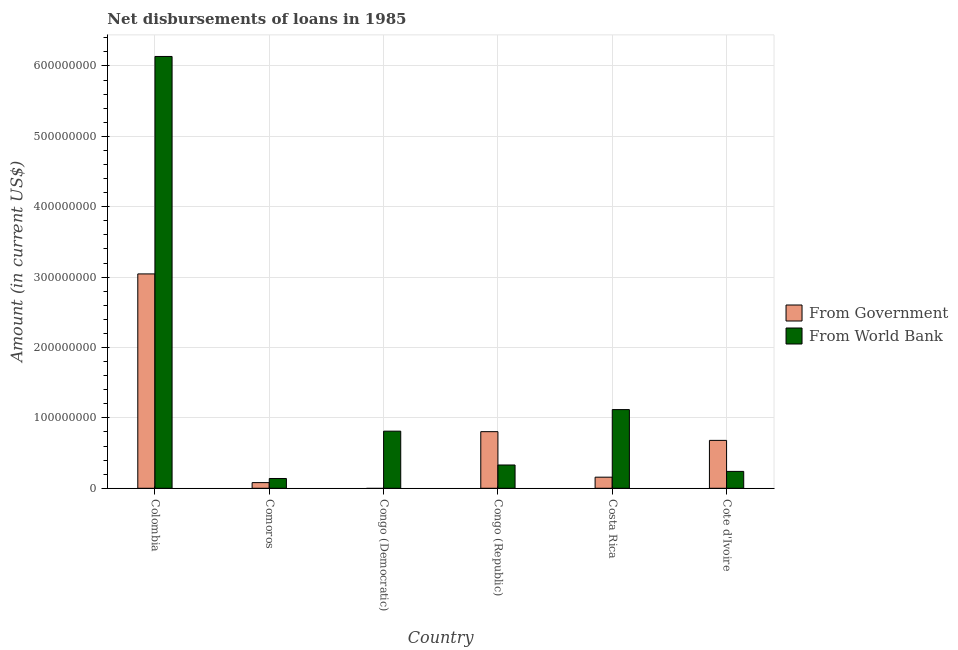How many different coloured bars are there?
Offer a very short reply. 2. How many bars are there on the 5th tick from the left?
Your answer should be compact. 2. What is the label of the 1st group of bars from the left?
Keep it short and to the point. Colombia. In how many cases, is the number of bars for a given country not equal to the number of legend labels?
Ensure brevity in your answer.  1. What is the net disbursements of loan from government in Congo (Democratic)?
Offer a very short reply. 0. Across all countries, what is the maximum net disbursements of loan from world bank?
Your response must be concise. 6.13e+08. Across all countries, what is the minimum net disbursements of loan from government?
Your answer should be very brief. 0. In which country was the net disbursements of loan from world bank maximum?
Offer a terse response. Colombia. What is the total net disbursements of loan from world bank in the graph?
Keep it short and to the point. 8.77e+08. What is the difference between the net disbursements of loan from world bank in Colombia and that in Congo (Republic)?
Ensure brevity in your answer.  5.80e+08. What is the difference between the net disbursements of loan from world bank in Congo (Democratic) and the net disbursements of loan from government in Colombia?
Keep it short and to the point. -2.23e+08. What is the average net disbursements of loan from government per country?
Provide a succinct answer. 7.95e+07. What is the difference between the net disbursements of loan from government and net disbursements of loan from world bank in Comoros?
Keep it short and to the point. -5.86e+06. In how many countries, is the net disbursements of loan from world bank greater than 340000000 US$?
Give a very brief answer. 1. What is the ratio of the net disbursements of loan from world bank in Congo (Republic) to that in Costa Rica?
Ensure brevity in your answer.  0.3. Is the difference between the net disbursements of loan from world bank in Colombia and Congo (Republic) greater than the difference between the net disbursements of loan from government in Colombia and Congo (Republic)?
Ensure brevity in your answer.  Yes. What is the difference between the highest and the second highest net disbursements of loan from government?
Provide a succinct answer. 2.24e+08. What is the difference between the highest and the lowest net disbursements of loan from government?
Your answer should be compact. 3.05e+08. In how many countries, is the net disbursements of loan from government greater than the average net disbursements of loan from government taken over all countries?
Keep it short and to the point. 2. Are all the bars in the graph horizontal?
Provide a succinct answer. No. Does the graph contain grids?
Your answer should be compact. Yes. Where does the legend appear in the graph?
Your answer should be very brief. Center right. How many legend labels are there?
Give a very brief answer. 2. How are the legend labels stacked?
Ensure brevity in your answer.  Vertical. What is the title of the graph?
Ensure brevity in your answer.  Net disbursements of loans in 1985. What is the label or title of the X-axis?
Make the answer very short. Country. What is the label or title of the Y-axis?
Ensure brevity in your answer.  Amount (in current US$). What is the Amount (in current US$) in From Government in Colombia?
Keep it short and to the point. 3.05e+08. What is the Amount (in current US$) in From World Bank in Colombia?
Keep it short and to the point. 6.13e+08. What is the Amount (in current US$) of From Government in Comoros?
Give a very brief answer. 8.06e+06. What is the Amount (in current US$) of From World Bank in Comoros?
Offer a very short reply. 1.39e+07. What is the Amount (in current US$) of From Government in Congo (Democratic)?
Provide a short and direct response. 0. What is the Amount (in current US$) in From World Bank in Congo (Democratic)?
Your answer should be very brief. 8.11e+07. What is the Amount (in current US$) in From Government in Congo (Republic)?
Ensure brevity in your answer.  8.04e+07. What is the Amount (in current US$) in From World Bank in Congo (Republic)?
Make the answer very short. 3.31e+07. What is the Amount (in current US$) in From Government in Costa Rica?
Make the answer very short. 1.58e+07. What is the Amount (in current US$) of From World Bank in Costa Rica?
Offer a very short reply. 1.12e+08. What is the Amount (in current US$) of From Government in Cote d'Ivoire?
Give a very brief answer. 6.80e+07. What is the Amount (in current US$) in From World Bank in Cote d'Ivoire?
Provide a short and direct response. 2.40e+07. Across all countries, what is the maximum Amount (in current US$) in From Government?
Your answer should be very brief. 3.05e+08. Across all countries, what is the maximum Amount (in current US$) in From World Bank?
Offer a terse response. 6.13e+08. Across all countries, what is the minimum Amount (in current US$) of From World Bank?
Provide a short and direct response. 1.39e+07. What is the total Amount (in current US$) of From Government in the graph?
Keep it short and to the point. 4.77e+08. What is the total Amount (in current US$) in From World Bank in the graph?
Your answer should be compact. 8.77e+08. What is the difference between the Amount (in current US$) in From Government in Colombia and that in Comoros?
Keep it short and to the point. 2.96e+08. What is the difference between the Amount (in current US$) of From World Bank in Colombia and that in Comoros?
Make the answer very short. 6.00e+08. What is the difference between the Amount (in current US$) of From World Bank in Colombia and that in Congo (Democratic)?
Provide a succinct answer. 5.32e+08. What is the difference between the Amount (in current US$) of From Government in Colombia and that in Congo (Republic)?
Provide a short and direct response. 2.24e+08. What is the difference between the Amount (in current US$) of From World Bank in Colombia and that in Congo (Republic)?
Ensure brevity in your answer.  5.80e+08. What is the difference between the Amount (in current US$) in From Government in Colombia and that in Costa Rica?
Ensure brevity in your answer.  2.89e+08. What is the difference between the Amount (in current US$) in From World Bank in Colombia and that in Costa Rica?
Provide a short and direct response. 5.02e+08. What is the difference between the Amount (in current US$) of From Government in Colombia and that in Cote d'Ivoire?
Your answer should be very brief. 2.36e+08. What is the difference between the Amount (in current US$) of From World Bank in Colombia and that in Cote d'Ivoire?
Your response must be concise. 5.89e+08. What is the difference between the Amount (in current US$) of From World Bank in Comoros and that in Congo (Democratic)?
Provide a short and direct response. -6.72e+07. What is the difference between the Amount (in current US$) in From Government in Comoros and that in Congo (Republic)?
Provide a succinct answer. -7.24e+07. What is the difference between the Amount (in current US$) of From World Bank in Comoros and that in Congo (Republic)?
Offer a terse response. -1.92e+07. What is the difference between the Amount (in current US$) of From Government in Comoros and that in Costa Rica?
Your answer should be compact. -7.72e+06. What is the difference between the Amount (in current US$) in From World Bank in Comoros and that in Costa Rica?
Provide a short and direct response. -9.79e+07. What is the difference between the Amount (in current US$) in From Government in Comoros and that in Cote d'Ivoire?
Your answer should be very brief. -6.00e+07. What is the difference between the Amount (in current US$) in From World Bank in Comoros and that in Cote d'Ivoire?
Your answer should be compact. -1.01e+07. What is the difference between the Amount (in current US$) of From World Bank in Congo (Democratic) and that in Congo (Republic)?
Offer a very short reply. 4.81e+07. What is the difference between the Amount (in current US$) of From World Bank in Congo (Democratic) and that in Costa Rica?
Keep it short and to the point. -3.06e+07. What is the difference between the Amount (in current US$) in From World Bank in Congo (Democratic) and that in Cote d'Ivoire?
Provide a succinct answer. 5.72e+07. What is the difference between the Amount (in current US$) of From Government in Congo (Republic) and that in Costa Rica?
Ensure brevity in your answer.  6.47e+07. What is the difference between the Amount (in current US$) in From World Bank in Congo (Republic) and that in Costa Rica?
Give a very brief answer. -7.87e+07. What is the difference between the Amount (in current US$) of From Government in Congo (Republic) and that in Cote d'Ivoire?
Provide a succinct answer. 1.24e+07. What is the difference between the Amount (in current US$) of From World Bank in Congo (Republic) and that in Cote d'Ivoire?
Offer a terse response. 9.10e+06. What is the difference between the Amount (in current US$) in From Government in Costa Rica and that in Cote d'Ivoire?
Ensure brevity in your answer.  -5.23e+07. What is the difference between the Amount (in current US$) in From World Bank in Costa Rica and that in Cote d'Ivoire?
Make the answer very short. 8.78e+07. What is the difference between the Amount (in current US$) of From Government in Colombia and the Amount (in current US$) of From World Bank in Comoros?
Give a very brief answer. 2.91e+08. What is the difference between the Amount (in current US$) in From Government in Colombia and the Amount (in current US$) in From World Bank in Congo (Democratic)?
Ensure brevity in your answer.  2.23e+08. What is the difference between the Amount (in current US$) in From Government in Colombia and the Amount (in current US$) in From World Bank in Congo (Republic)?
Make the answer very short. 2.71e+08. What is the difference between the Amount (in current US$) in From Government in Colombia and the Amount (in current US$) in From World Bank in Costa Rica?
Provide a short and direct response. 1.93e+08. What is the difference between the Amount (in current US$) of From Government in Colombia and the Amount (in current US$) of From World Bank in Cote d'Ivoire?
Offer a very short reply. 2.81e+08. What is the difference between the Amount (in current US$) in From Government in Comoros and the Amount (in current US$) in From World Bank in Congo (Democratic)?
Ensure brevity in your answer.  -7.31e+07. What is the difference between the Amount (in current US$) of From Government in Comoros and the Amount (in current US$) of From World Bank in Congo (Republic)?
Your answer should be compact. -2.50e+07. What is the difference between the Amount (in current US$) of From Government in Comoros and the Amount (in current US$) of From World Bank in Costa Rica?
Provide a short and direct response. -1.04e+08. What is the difference between the Amount (in current US$) in From Government in Comoros and the Amount (in current US$) in From World Bank in Cote d'Ivoire?
Your answer should be very brief. -1.59e+07. What is the difference between the Amount (in current US$) of From Government in Congo (Republic) and the Amount (in current US$) of From World Bank in Costa Rica?
Ensure brevity in your answer.  -3.14e+07. What is the difference between the Amount (in current US$) of From Government in Congo (Republic) and the Amount (in current US$) of From World Bank in Cote d'Ivoire?
Make the answer very short. 5.64e+07. What is the difference between the Amount (in current US$) in From Government in Costa Rica and the Amount (in current US$) in From World Bank in Cote d'Ivoire?
Offer a very short reply. -8.22e+06. What is the average Amount (in current US$) in From Government per country?
Your answer should be compact. 7.95e+07. What is the average Amount (in current US$) in From World Bank per country?
Offer a very short reply. 1.46e+08. What is the difference between the Amount (in current US$) in From Government and Amount (in current US$) in From World Bank in Colombia?
Offer a very short reply. -3.09e+08. What is the difference between the Amount (in current US$) in From Government and Amount (in current US$) in From World Bank in Comoros?
Your response must be concise. -5.86e+06. What is the difference between the Amount (in current US$) of From Government and Amount (in current US$) of From World Bank in Congo (Republic)?
Provide a succinct answer. 4.73e+07. What is the difference between the Amount (in current US$) of From Government and Amount (in current US$) of From World Bank in Costa Rica?
Your answer should be very brief. -9.60e+07. What is the difference between the Amount (in current US$) of From Government and Amount (in current US$) of From World Bank in Cote d'Ivoire?
Make the answer very short. 4.41e+07. What is the ratio of the Amount (in current US$) of From Government in Colombia to that in Comoros?
Give a very brief answer. 37.8. What is the ratio of the Amount (in current US$) in From World Bank in Colombia to that in Comoros?
Give a very brief answer. 44.09. What is the ratio of the Amount (in current US$) of From World Bank in Colombia to that in Congo (Democratic)?
Offer a very short reply. 7.56. What is the ratio of the Amount (in current US$) of From Government in Colombia to that in Congo (Republic)?
Provide a succinct answer. 3.79. What is the ratio of the Amount (in current US$) of From World Bank in Colombia to that in Congo (Republic)?
Offer a terse response. 18.54. What is the ratio of the Amount (in current US$) in From Government in Colombia to that in Costa Rica?
Keep it short and to the point. 19.31. What is the ratio of the Amount (in current US$) of From World Bank in Colombia to that in Costa Rica?
Offer a terse response. 5.49. What is the ratio of the Amount (in current US$) of From Government in Colombia to that in Cote d'Ivoire?
Keep it short and to the point. 4.48. What is the ratio of the Amount (in current US$) in From World Bank in Colombia to that in Cote d'Ivoire?
Offer a terse response. 25.57. What is the ratio of the Amount (in current US$) in From World Bank in Comoros to that in Congo (Democratic)?
Your answer should be very brief. 0.17. What is the ratio of the Amount (in current US$) of From Government in Comoros to that in Congo (Republic)?
Give a very brief answer. 0.1. What is the ratio of the Amount (in current US$) in From World Bank in Comoros to that in Congo (Republic)?
Your answer should be compact. 0.42. What is the ratio of the Amount (in current US$) of From Government in Comoros to that in Costa Rica?
Give a very brief answer. 0.51. What is the ratio of the Amount (in current US$) in From World Bank in Comoros to that in Costa Rica?
Your answer should be very brief. 0.12. What is the ratio of the Amount (in current US$) in From Government in Comoros to that in Cote d'Ivoire?
Make the answer very short. 0.12. What is the ratio of the Amount (in current US$) in From World Bank in Comoros to that in Cote d'Ivoire?
Make the answer very short. 0.58. What is the ratio of the Amount (in current US$) of From World Bank in Congo (Democratic) to that in Congo (Republic)?
Provide a short and direct response. 2.45. What is the ratio of the Amount (in current US$) in From World Bank in Congo (Democratic) to that in Costa Rica?
Provide a short and direct response. 0.73. What is the ratio of the Amount (in current US$) in From World Bank in Congo (Democratic) to that in Cote d'Ivoire?
Your answer should be compact. 3.38. What is the ratio of the Amount (in current US$) of From Government in Congo (Republic) to that in Costa Rica?
Offer a terse response. 5.1. What is the ratio of the Amount (in current US$) in From World Bank in Congo (Republic) to that in Costa Rica?
Make the answer very short. 0.3. What is the ratio of the Amount (in current US$) of From Government in Congo (Republic) to that in Cote d'Ivoire?
Your answer should be very brief. 1.18. What is the ratio of the Amount (in current US$) in From World Bank in Congo (Republic) to that in Cote d'Ivoire?
Provide a short and direct response. 1.38. What is the ratio of the Amount (in current US$) in From Government in Costa Rica to that in Cote d'Ivoire?
Offer a terse response. 0.23. What is the ratio of the Amount (in current US$) of From World Bank in Costa Rica to that in Cote d'Ivoire?
Ensure brevity in your answer.  4.66. What is the difference between the highest and the second highest Amount (in current US$) in From Government?
Your answer should be compact. 2.24e+08. What is the difference between the highest and the second highest Amount (in current US$) in From World Bank?
Make the answer very short. 5.02e+08. What is the difference between the highest and the lowest Amount (in current US$) of From Government?
Your response must be concise. 3.05e+08. What is the difference between the highest and the lowest Amount (in current US$) of From World Bank?
Keep it short and to the point. 6.00e+08. 